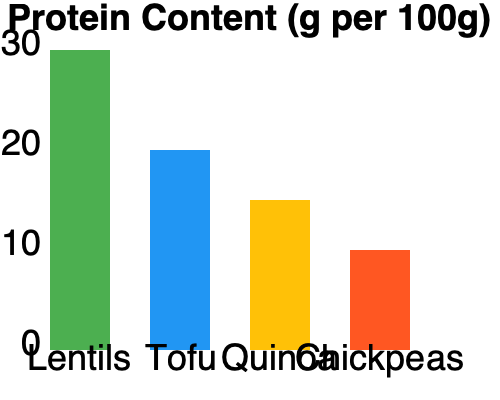Based on the bar graph showing the protein content of various vegetarian ingredients, calculate the total protein content of a meal containing 150g of lentils, 200g of tofu, and 100g of chickpeas. Express your answer in grams. To solve this problem, we need to follow these steps:

1. Determine the protein content per 100g for each ingredient:
   - Lentils: 30g per 100g
   - Tofu: 20g per 100g
   - Chickpeas: 10g per 100g

2. Calculate the protein content for each ingredient based on the given amounts:
   - Lentils: $\frac{150g}{100g} \times 30g = 1.5 \times 30g = 45g$
   - Tofu: $\frac{200g}{100g} \times 20g = 2 \times 20g = 40g$
   - Chickpeas: $\frac{100g}{100g} \times 10g = 1 \times 10g = 10g$

3. Sum up the protein content from all ingredients:
   $45g + 40g + 10g = 95g$

Therefore, the total protein content of the meal is 95g.
Answer: 95g 